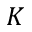Convert formula to latex. <formula><loc_0><loc_0><loc_500><loc_500>K</formula> 